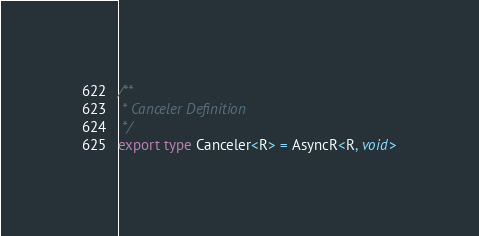Convert code to text. <code><loc_0><loc_0><loc_500><loc_500><_TypeScript_>/**
 * Canceler Definition
 */
export type Canceler<R> = AsyncR<R, void>
</code> 